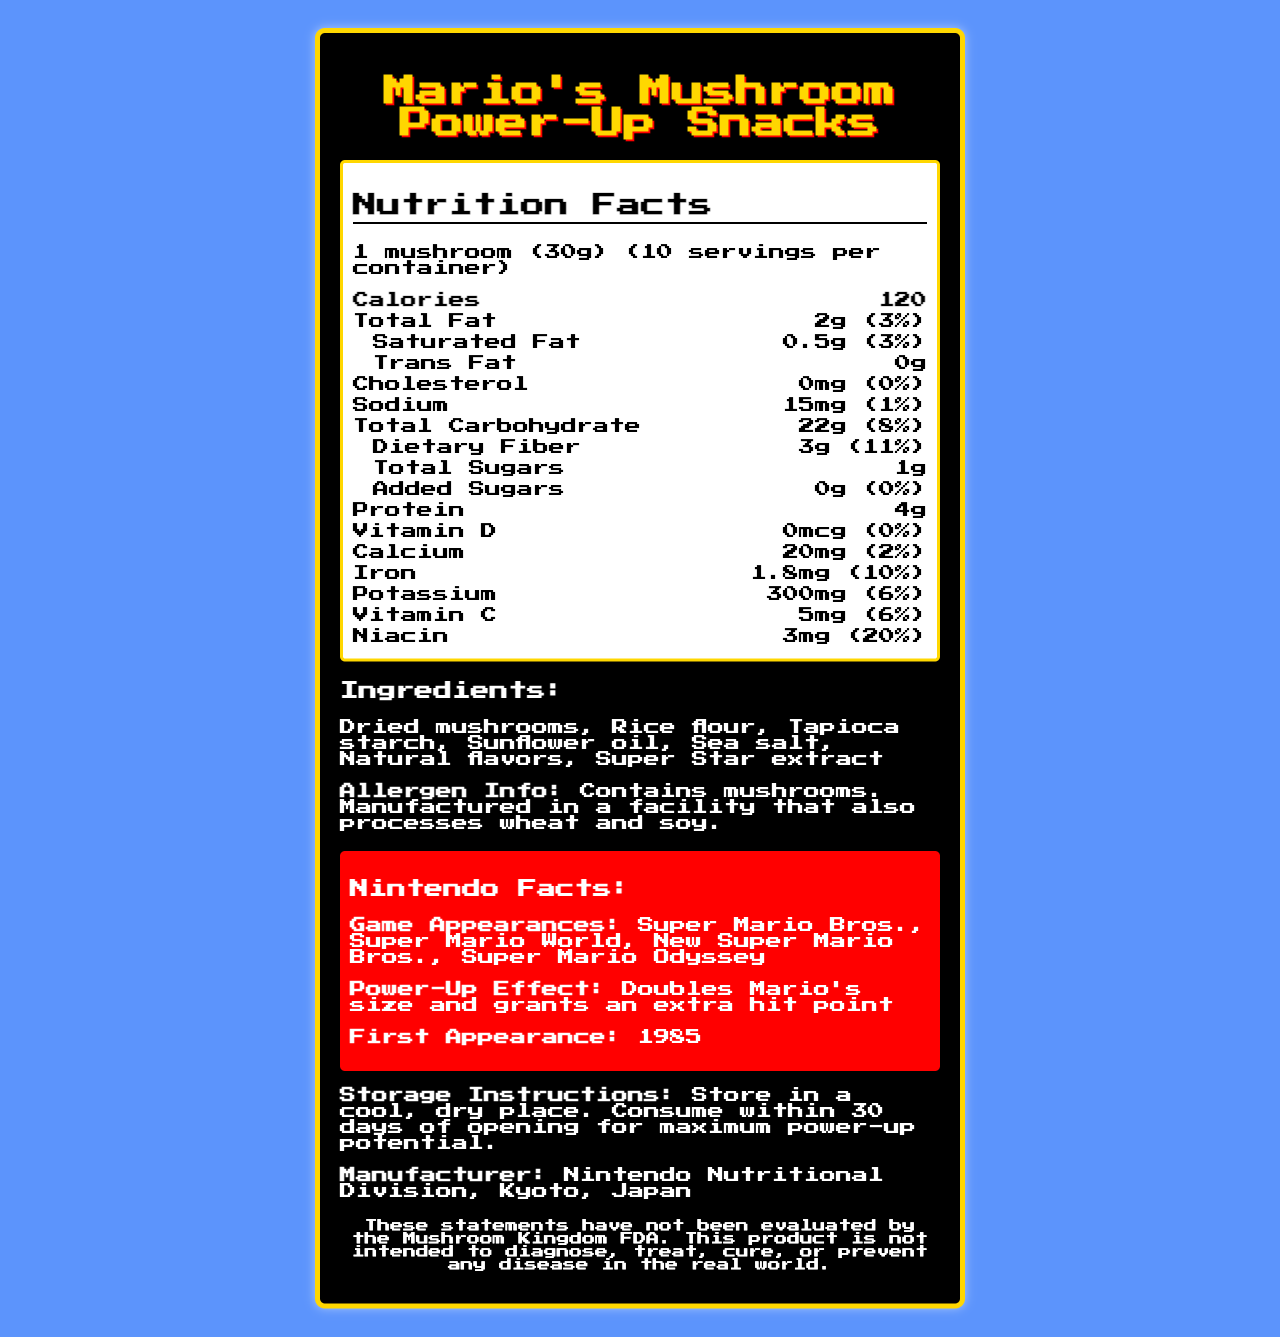what is the serving size for Mario's Mushroom Power-Up Snacks? The document specifies the serving size as "1 mushroom (30g)".
Answer: 1 mushroom (30g) How many calories are in one serving? The document lists the calorie count per serving as 120.
Answer: 120 calories Which vitamins and nutrients have the highest daily value percentage? The document mentions niacin with a daily value of 20%, which is the highest among listed vitamins and nutrients.
Answer: Niacin (20%) What is the power-up effect of Mario's Mushroom Power-Up Snacks in the games? The Nintendo Facts section explains that the power-up effect is to double Mario's size and grant an extra hit point.
Answer: Doubles Mario's size and grants an extra hit point How many grams of total fat are in one serving? The document lists 2g of total fat per serving.
Answer: 2g What are the ingredients of Mario's Mushroom Power-Up Snacks? A. Dried mushrooms, Rice flour, Sea salt B. Dried mushrooms, Rice flour, Tapioca starch, Sea salt C. Dried mushrooms, Rice flour, Tapioca starch, Natural flavors The ingredients listed in the document are dried mushrooms, Rice flour, Tapioca starch, Sunflower oil, Sea salt, Natural flavors, and Super Star extract.
Answer: B. Dried mushrooms, Rice flour, Tapioca starch, Sea salt Which of the following games did Mario's Mushroom first appear in? i. Super Mario Bros. ii. Super Mario Odyssey iii. Super Mario World iv. New Super Mario Bros. According to the Nintendo Facts section, Mario's Mushroom first appeared in Super Mario Bros.
Answer: i.  Super Mario Bros. Is Mario's Mushroom Power-Up Snacks a good source of dietary fiber? The document shows that each serving contains 3g of dietary fiber, which is 11% of the daily value, indicating a good source of dietary fiber.
Answer: Yes Determine if Mario's Mushroom snacks contain any cholesterol. The document states that the cholesterol amount is 0mg (0% daily value).
Answer: No Summarize the document. The detailed summary of the document includes the nutritional information, ingredient list, Nintendo facts, storage instructions, manufacturer, and a disclaimer about the product's fictional purpose.
Answer: The document provides detailed nutrition facts and other information about Mario's Mushroom Power-Up Snacks, a fictional product by Nintendo. It describes the serving size, nutritional content including calories, fats, proteins, vitamins, and minerals, along with ingredient and allergen info. It also mentions the product's appearances in various Mario games, power-up effects, and first appearance year. Storage instructions and manufacturer details are included as well. How many large mushrooms should you eat to get 30% of your daily fiber intake? The document does not specify how many grams of dietary fiber are in the daily recommended intake, hence the number of servings needed to meet 30% of the daily intake cannot be calculated without additional information.
Answer: Cannot be determined 